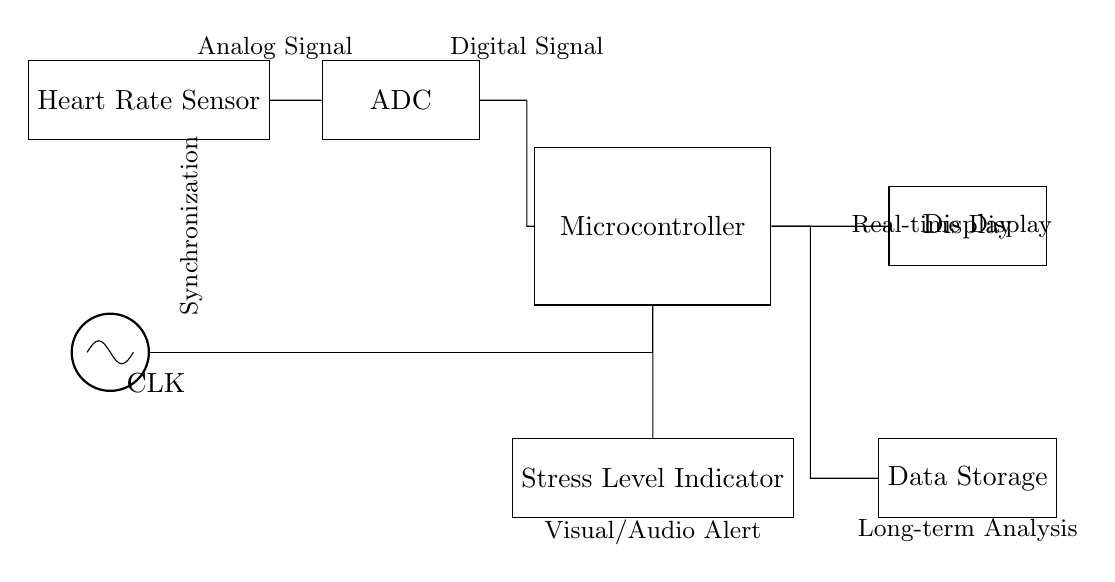What component is used to convert analog signals to digital? The component used for this purpose is the Analog to Digital Converter (ADC). It takes the analog signal from the heart rate sensor and converts it to a digital signal for processing.
Answer: Analog to Digital Converter What is the primary function of the microcontroller in this circuit? The primary function of the microcontroller (MCU) is to process the digital signal received from the ADC and make decisions based on that data. This includes displaying information and triggering alerts.
Answer: Process signals What type of output does the heart rate sensor provide? The heart rate sensor provides an analog signal that represents the heart rate data measured from the user. This signal needs to be processed to be useful in digital formats.
Answer: Analog signal How are the clock signals synchronized in this circuit? The clock signals are synchronized by connecting them directly to the microcontroller from the clock generator. This ensures that all parts of the circuit operate at the same timing.
Answer: Clock generator What does the stress level indicator do? The stress level indicator visually or audibly alerts the user about their stress levels based on the processed heart rate data from the microcontroller.
Answer: Provides alerts What is the purpose of the data storage component in this circuit? The data storage component is designed to store long-term heart rate information and stress levels for analysis and later retrieval. This allows for tracking patterns over time.
Answer: Long-term analysis What type of signal does the microcontroller output to the display? The microcontroller outputs a digital signal to the display, which shows the processed heart rate and stress level information to the user in a human-readable format.
Answer: Digital signal 